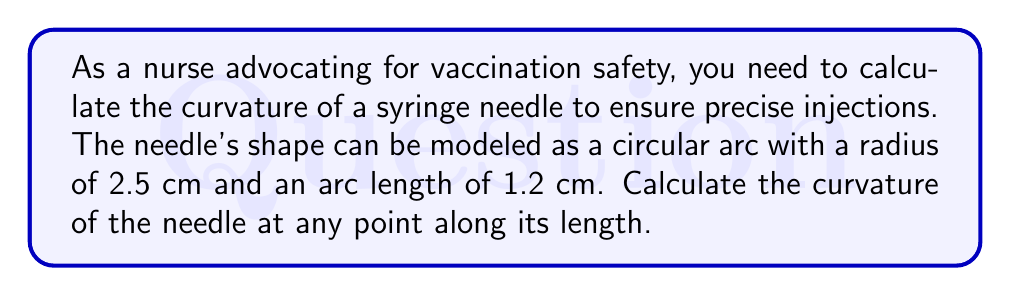Can you solve this math problem? To calculate the curvature of the syringe needle, we'll use the formula for the curvature of a circular arc:

1. The curvature ($\kappa$) of a circle is the reciprocal of its radius ($r$):

   $$\kappa = \frac{1}{r}$$

2. Given:
   - Radius ($r$) = 2.5 cm
   - Arc length ($s$) = 1.2 cm (not needed for this calculation)

3. Substitute the radius into the curvature formula:

   $$\kappa = \frac{1}{2.5} \text{ cm}^{-1}$$

4. Simplify:

   $$\kappa = 0.4 \text{ cm}^{-1}$$

5. Note: The curvature is constant along the entire length of the circular arc, so it's the same at any point on the needle.

This curvature value indicates how sharply the needle bends. A higher curvature would mean a more sharply bent needle, while a lower curvature would indicate a straighter needle.
Answer: $0.4 \text{ cm}^{-1}$ 